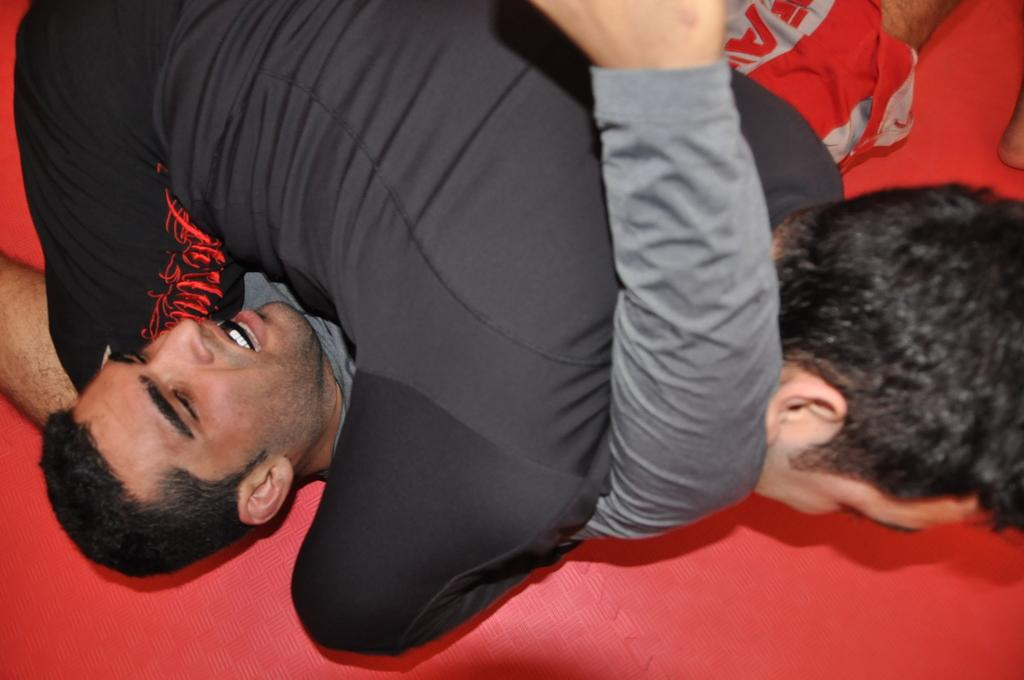What are the persons in the image doing? The persons in the image are lying on a bed. What is the color of the bed? The bed is red in color. What type of bun can be seen on the bed in the image? There is no bun present on the bed in the image. What is the persons' level of fear while lying on the bed in the image? The level of fear cannot be determined from the image, as there is no indication of fear or any emotional state. 